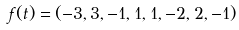<formula> <loc_0><loc_0><loc_500><loc_500>f ( t ) = ( - 3 , 3 , - 1 , 1 , 1 , - 2 , 2 , - 1 )</formula> 